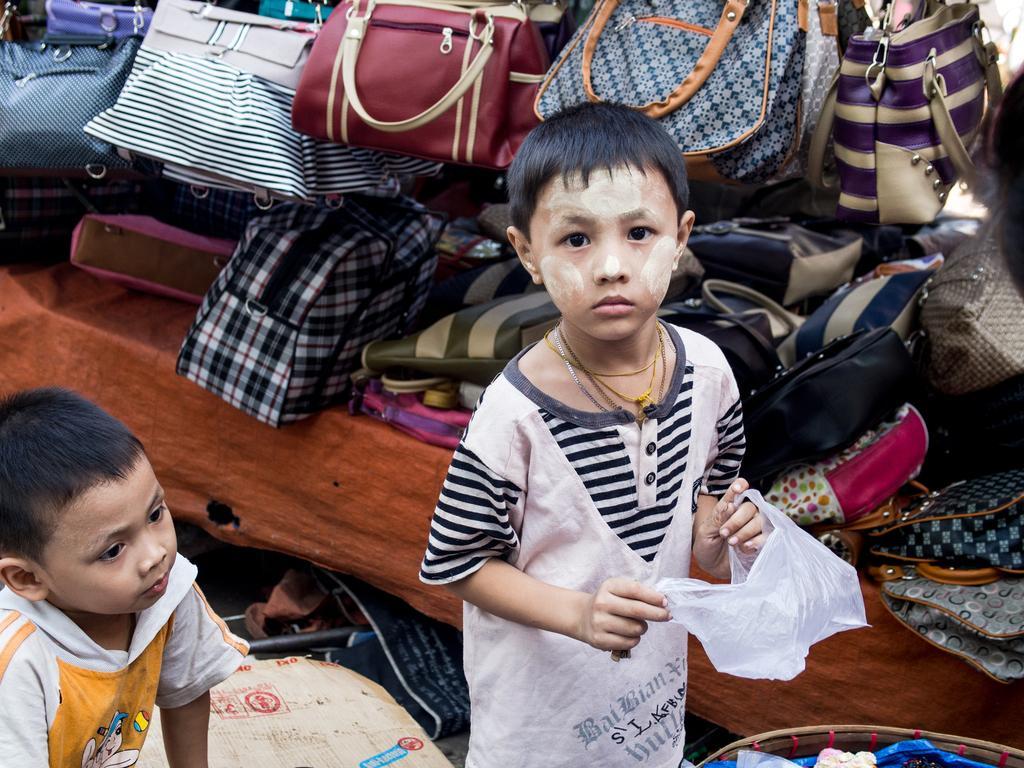In one or two sentences, can you explain what this image depicts? In this picture I can see there are two boys standing and the boy at the right side is holding a carrier bag and there is another boy at left side he is looking at the right side. In the backdrop, there are hand bags and there is a carton box on the floor. 